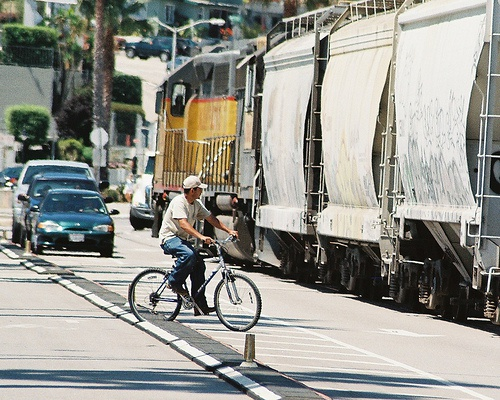Describe the objects in this image and their specific colors. I can see train in gray, lightgray, black, and darkgray tones, bicycle in gray, lightgray, black, and darkgray tones, car in gray, black, blue, darkblue, and teal tones, people in gray, black, ivory, and darkgray tones, and car in gray, blue, and black tones in this image. 